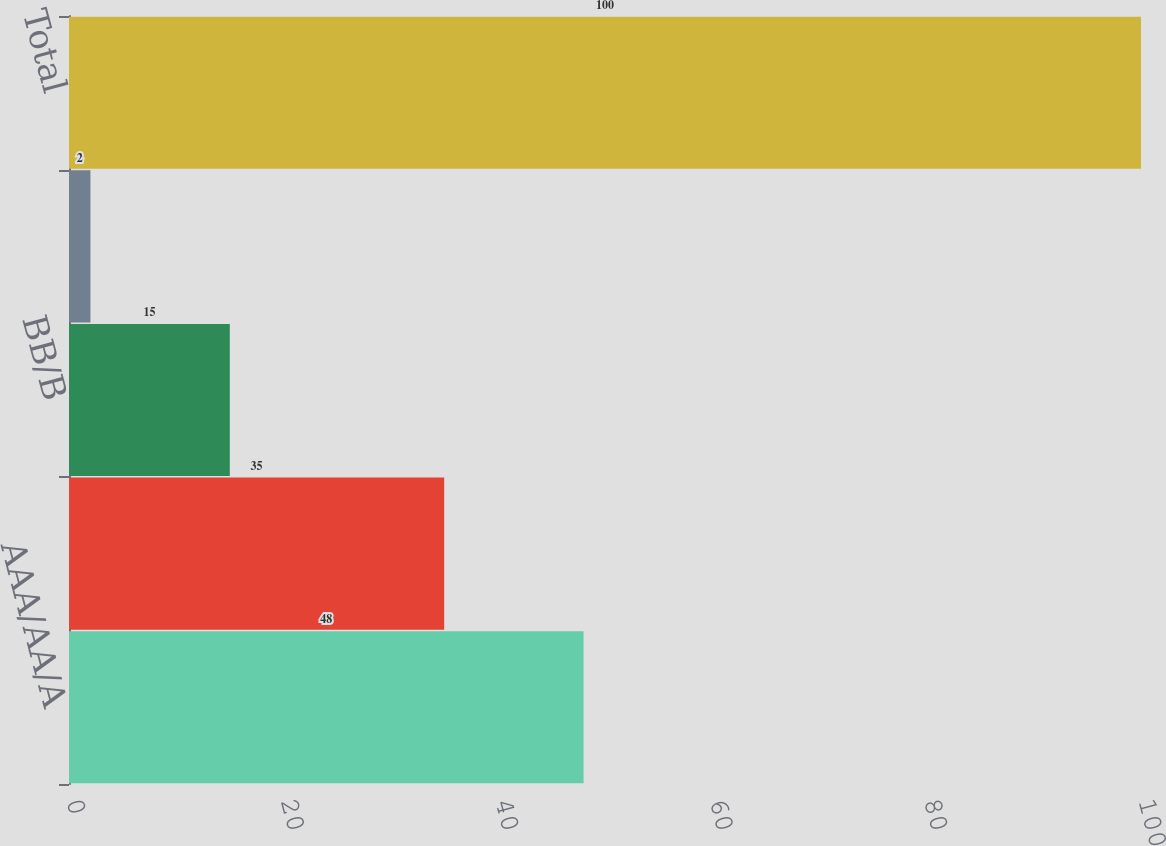Convert chart to OTSL. <chart><loc_0><loc_0><loc_500><loc_500><bar_chart><fcel>AAA/AA/A<fcel>BBB<fcel>BB/B<fcel>CCC or below<fcel>Total<nl><fcel>48<fcel>35<fcel>15<fcel>2<fcel>100<nl></chart> 